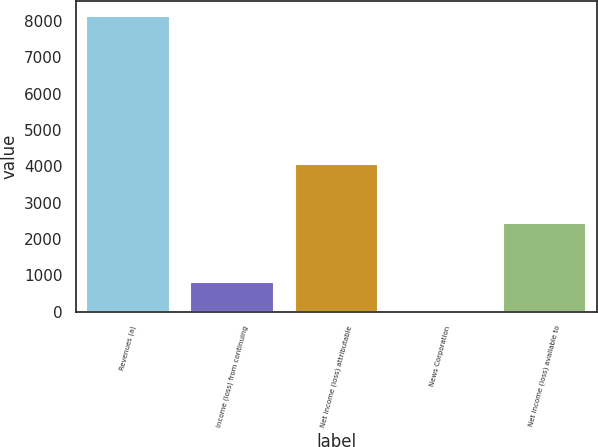<chart> <loc_0><loc_0><loc_500><loc_500><bar_chart><fcel>Revenues (a)<fcel>Income (loss) from continuing<fcel>Net income (loss) attributable<fcel>News Corporation<fcel>Net income (loss) available to<nl><fcel>8139<fcel>815.04<fcel>4070.12<fcel>1.27<fcel>2442.58<nl></chart> 